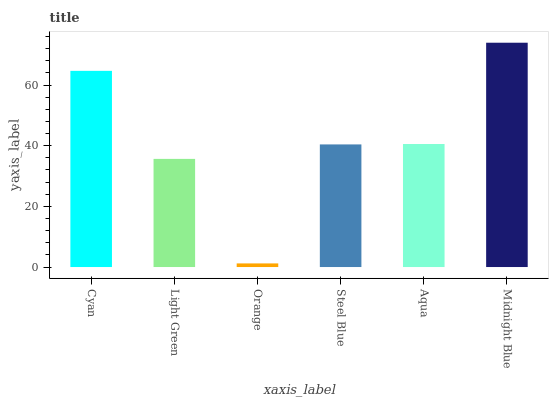Is Light Green the minimum?
Answer yes or no. No. Is Light Green the maximum?
Answer yes or no. No. Is Cyan greater than Light Green?
Answer yes or no. Yes. Is Light Green less than Cyan?
Answer yes or no. Yes. Is Light Green greater than Cyan?
Answer yes or no. No. Is Cyan less than Light Green?
Answer yes or no. No. Is Aqua the high median?
Answer yes or no. Yes. Is Steel Blue the low median?
Answer yes or no. Yes. Is Midnight Blue the high median?
Answer yes or no. No. Is Aqua the low median?
Answer yes or no. No. 